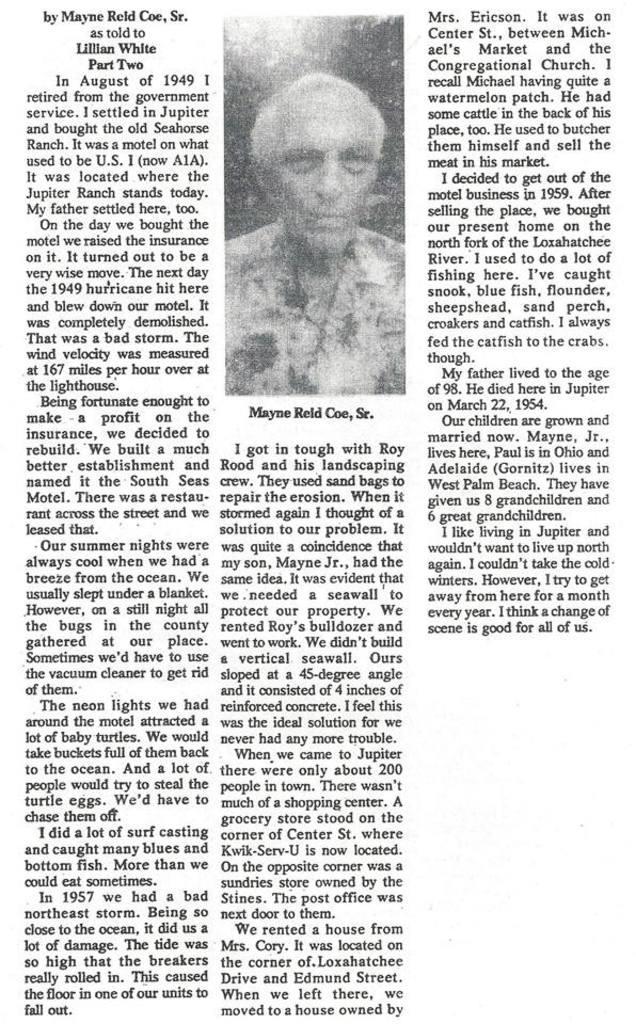Please provide a concise description of this image. In the picture I can see the photo of a man and there is a garland on his neck. I can see the text in the picture. 